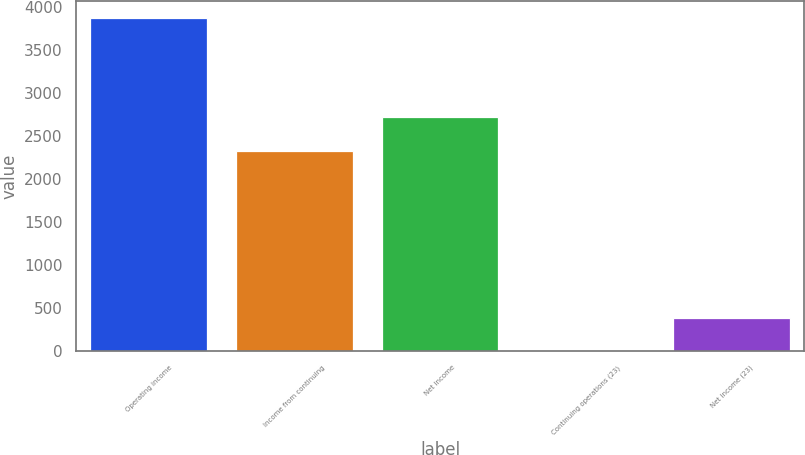Convert chart. <chart><loc_0><loc_0><loc_500><loc_500><bar_chart><fcel>Operating income<fcel>Income from continuing<fcel>Net income<fcel>Continuing operations (23)<fcel>Net income (23)<nl><fcel>3879<fcel>2335<fcel>2722.71<fcel>1.93<fcel>389.64<nl></chart> 